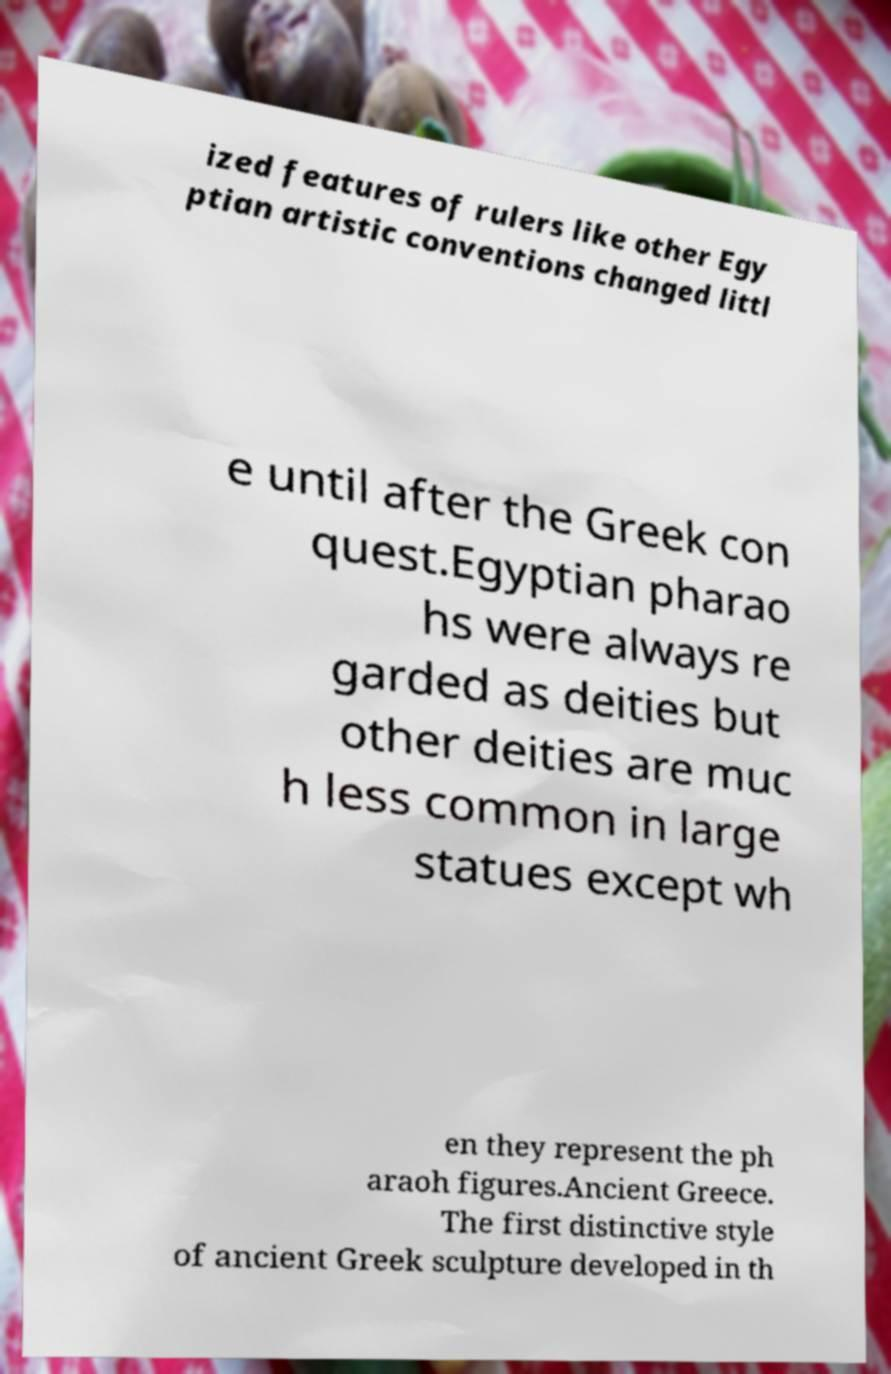Please read and relay the text visible in this image. What does it say? ized features of rulers like other Egy ptian artistic conventions changed littl e until after the Greek con quest.Egyptian pharao hs were always re garded as deities but other deities are muc h less common in large statues except wh en they represent the ph araoh figures.Ancient Greece. The first distinctive style of ancient Greek sculpture developed in th 